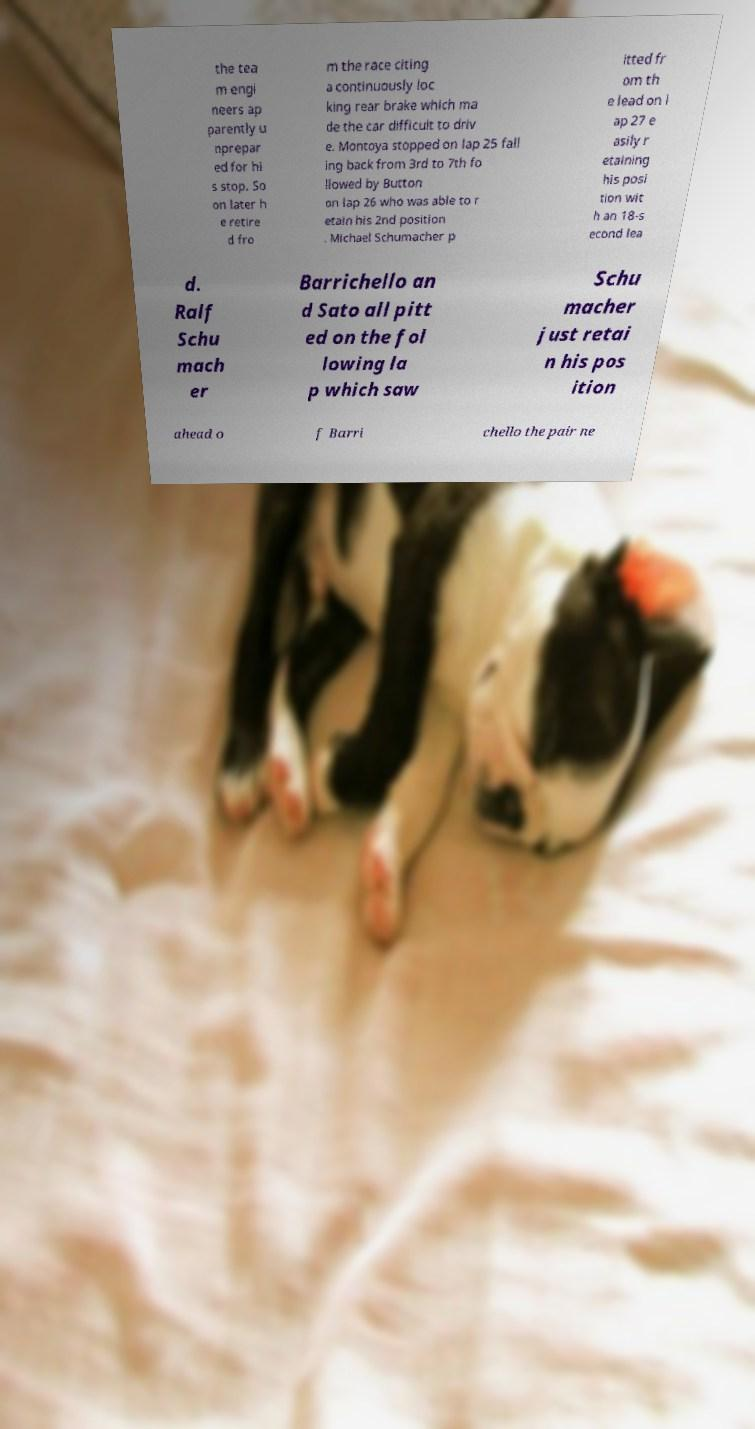There's text embedded in this image that I need extracted. Can you transcribe it verbatim? the tea m engi neers ap parently u nprepar ed for hi s stop. So on later h e retire d fro m the race citing a continuously loc king rear brake which ma de the car difficult to driv e. Montoya stopped on lap 25 fall ing back from 3rd to 7th fo llowed by Button on lap 26 who was able to r etain his 2nd position . Michael Schumacher p itted fr om th e lead on l ap 27 e asily r etaining his posi tion wit h an 18-s econd lea d. Ralf Schu mach er Barrichello an d Sato all pitt ed on the fol lowing la p which saw Schu macher just retai n his pos ition ahead o f Barri chello the pair ne 